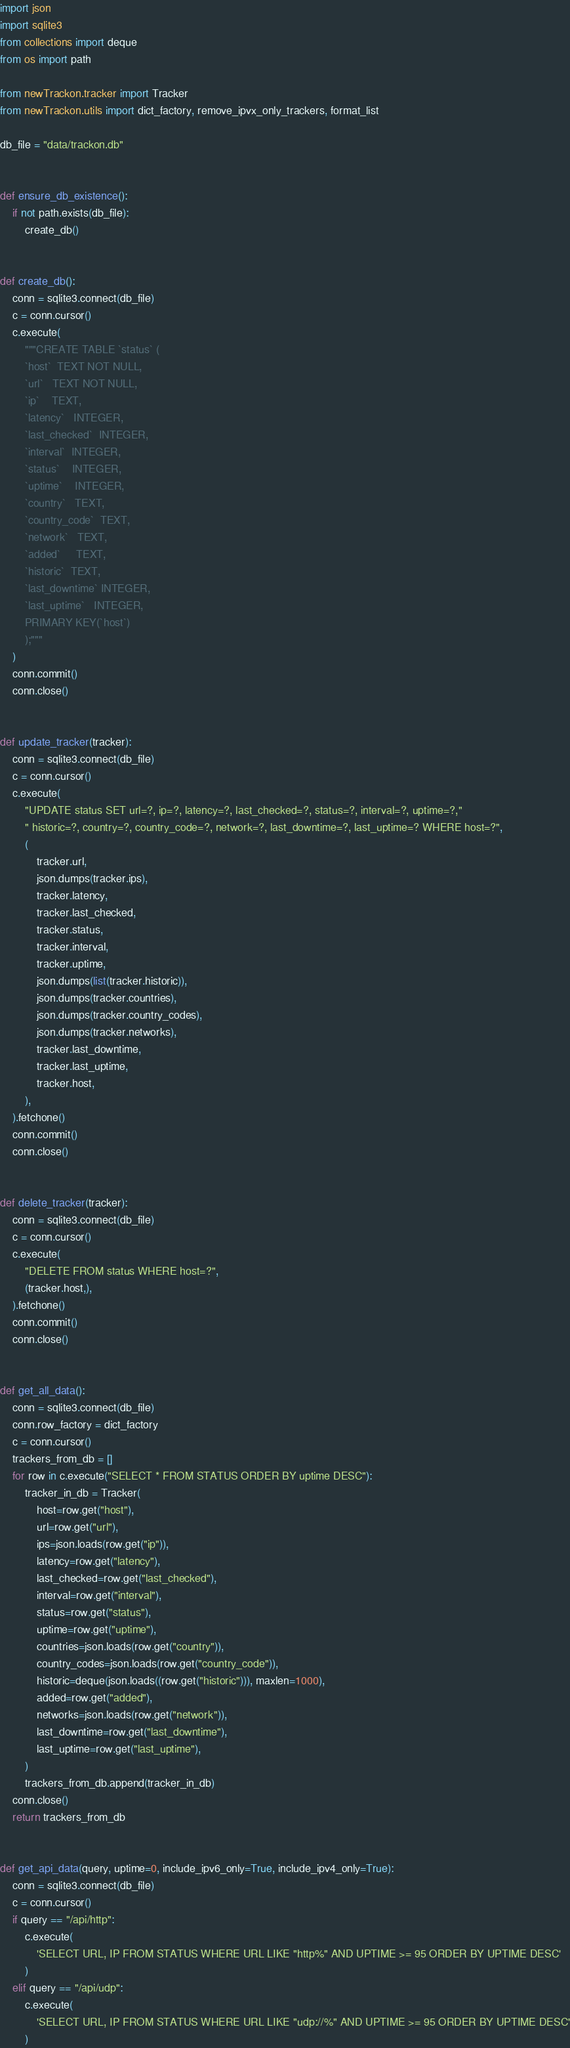Convert code to text. <code><loc_0><loc_0><loc_500><loc_500><_Python_>import json
import sqlite3
from collections import deque
from os import path

from newTrackon.tracker import Tracker
from newTrackon.utils import dict_factory, remove_ipvx_only_trackers, format_list

db_file = "data/trackon.db"


def ensure_db_existence():
    if not path.exists(db_file):
        create_db()


def create_db():
    conn = sqlite3.connect(db_file)
    c = conn.cursor()
    c.execute(
        """CREATE TABLE `status` (
        `host`	TEXT NOT NULL,
        `url`	TEXT NOT NULL,
        `ip`	TEXT,
        `latency`	INTEGER,
        `last_checked`	INTEGER,
        `interval`	INTEGER,
        `status`	INTEGER,
        `uptime`	INTEGER,
        `country`	TEXT,
        `country_code`	TEXT,
        `network`	TEXT,
        `added`		TEXT,
        `historic`	TEXT,
        `last_downtime` INTEGER,
        `last_uptime`	INTEGER,
        PRIMARY KEY(`host`)
        );"""
    )
    conn.commit()
    conn.close()


def update_tracker(tracker):
    conn = sqlite3.connect(db_file)
    c = conn.cursor()
    c.execute(
        "UPDATE status SET url=?, ip=?, latency=?, last_checked=?, status=?, interval=?, uptime=?,"
        " historic=?, country=?, country_code=?, network=?, last_downtime=?, last_uptime=? WHERE host=?",
        (
            tracker.url,
            json.dumps(tracker.ips),
            tracker.latency,
            tracker.last_checked,
            tracker.status,
            tracker.interval,
            tracker.uptime,
            json.dumps(list(tracker.historic)),
            json.dumps(tracker.countries),
            json.dumps(tracker.country_codes),
            json.dumps(tracker.networks),
            tracker.last_downtime,
            tracker.last_uptime,
            tracker.host,
        ),
    ).fetchone()
    conn.commit()
    conn.close()


def delete_tracker(tracker):
    conn = sqlite3.connect(db_file)
    c = conn.cursor()
    c.execute(
        "DELETE FROM status WHERE host=?",
        (tracker.host,),
    ).fetchone()
    conn.commit()
    conn.close()


def get_all_data():
    conn = sqlite3.connect(db_file)
    conn.row_factory = dict_factory
    c = conn.cursor()
    trackers_from_db = []
    for row in c.execute("SELECT * FROM STATUS ORDER BY uptime DESC"):
        tracker_in_db = Tracker(
            host=row.get("host"),
            url=row.get("url"),
            ips=json.loads(row.get("ip")),
            latency=row.get("latency"),
            last_checked=row.get("last_checked"),
            interval=row.get("interval"),
            status=row.get("status"),
            uptime=row.get("uptime"),
            countries=json.loads(row.get("country")),
            country_codes=json.loads(row.get("country_code")),
            historic=deque(json.loads((row.get("historic"))), maxlen=1000),
            added=row.get("added"),
            networks=json.loads(row.get("network")),
            last_downtime=row.get("last_downtime"),
            last_uptime=row.get("last_uptime"),
        )
        trackers_from_db.append(tracker_in_db)
    conn.close()
    return trackers_from_db


def get_api_data(query, uptime=0, include_ipv6_only=True, include_ipv4_only=True):
    conn = sqlite3.connect(db_file)
    c = conn.cursor()
    if query == "/api/http":
        c.execute(
            'SELECT URL, IP FROM STATUS WHERE URL LIKE "http%" AND UPTIME >= 95 ORDER BY UPTIME DESC'
        )
    elif query == "/api/udp":
        c.execute(
            'SELECT URL, IP FROM STATUS WHERE URL LIKE "udp://%" AND UPTIME >= 95 ORDER BY UPTIME DESC'
        )</code> 